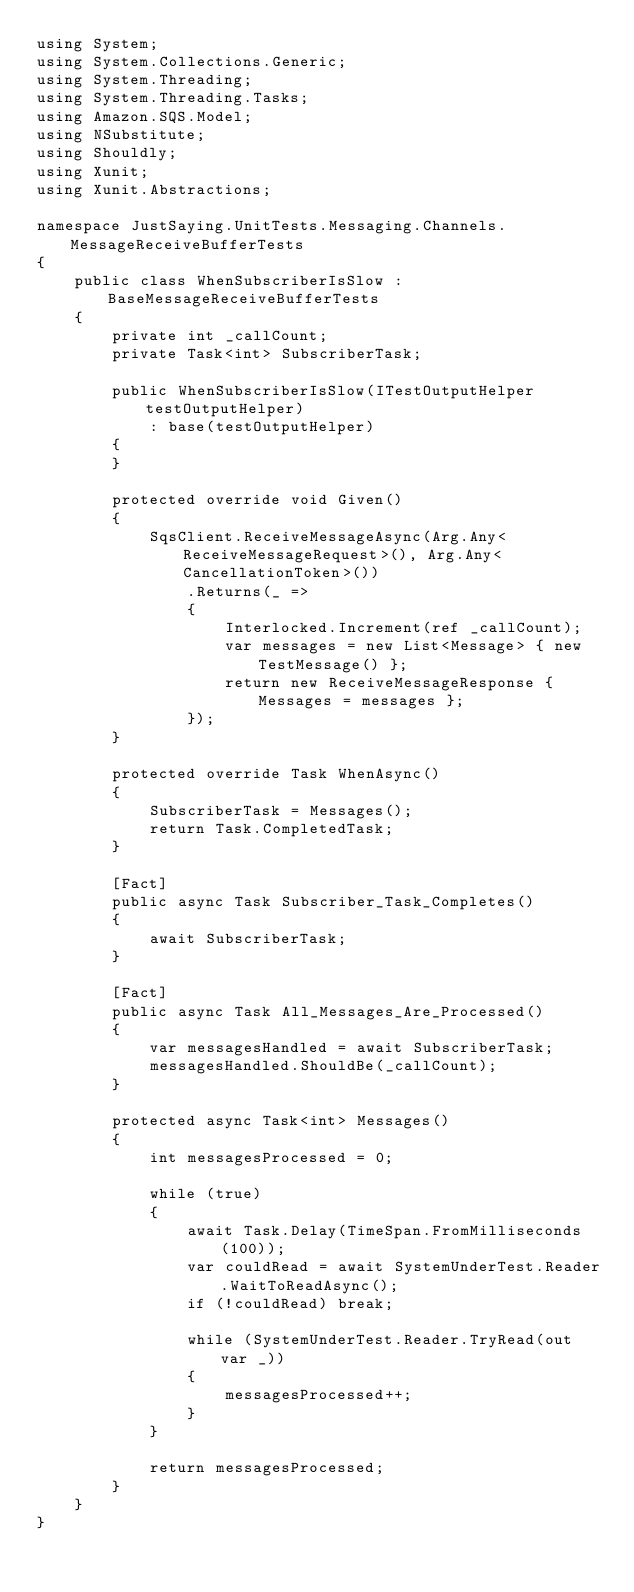Convert code to text. <code><loc_0><loc_0><loc_500><loc_500><_C#_>using System;
using System.Collections.Generic;
using System.Threading;
using System.Threading.Tasks;
using Amazon.SQS.Model;
using NSubstitute;
using Shouldly;
using Xunit;
using Xunit.Abstractions;

namespace JustSaying.UnitTests.Messaging.Channels.MessageReceiveBufferTests
{
    public class WhenSubscriberIsSlow : BaseMessageReceiveBufferTests
    {
        private int _callCount;
        private Task<int> SubscriberTask;

        public WhenSubscriberIsSlow(ITestOutputHelper testOutputHelper)
            : base(testOutputHelper)
        {
        }

        protected override void Given()
        {
            SqsClient.ReceiveMessageAsync(Arg.Any<ReceiveMessageRequest>(), Arg.Any<CancellationToken>())
                .Returns(_ =>
                {
                    Interlocked.Increment(ref _callCount);
                    var messages = new List<Message> { new TestMessage() };
                    return new ReceiveMessageResponse { Messages = messages };
                });
        }

        protected override Task WhenAsync()
        {
            SubscriberTask = Messages();
            return Task.CompletedTask;
        }

        [Fact]
        public async Task Subscriber_Task_Completes()
        {
            await SubscriberTask;
        }

        [Fact]
        public async Task All_Messages_Are_Processed()
        {
            var messagesHandled = await SubscriberTask;
            messagesHandled.ShouldBe(_callCount);
        }

        protected async Task<int> Messages()
        {
            int messagesProcessed = 0;

            while (true)
            {
                await Task.Delay(TimeSpan.FromMilliseconds(100));
                var couldRead = await SystemUnderTest.Reader.WaitToReadAsync();
                if (!couldRead) break;

                while (SystemUnderTest.Reader.TryRead(out var _))
                {
                    messagesProcessed++;
                }
            }

            return messagesProcessed;
        }
    }
}
</code> 